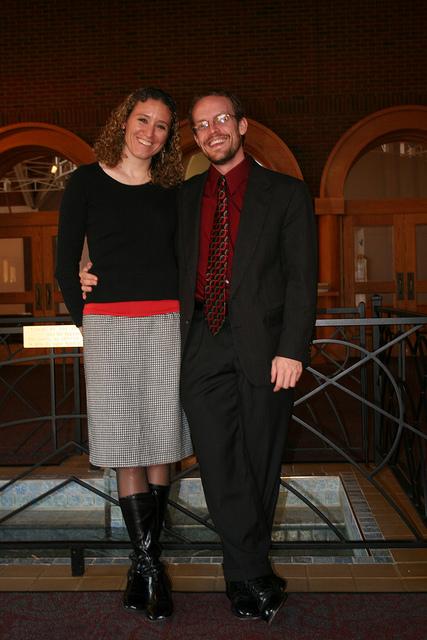Does this photo have a border?
Be succinct. No. What color is the woman's skirt?
Short answer required. Black and white. Are they dressed for a formal date?
Concise answer only. Yes. What brand of shoes is the person on the left wearing?
Be succinct. Can't tell. What are the front two people doing?
Keep it brief. Posing. How many women are here?
Concise answer only. 1. What is in the glass container behind the man?
Short answer required. Cabinet. Where are they standing?
Quick response, please. Inside. Is the boy moving?
Write a very short answer. No. 